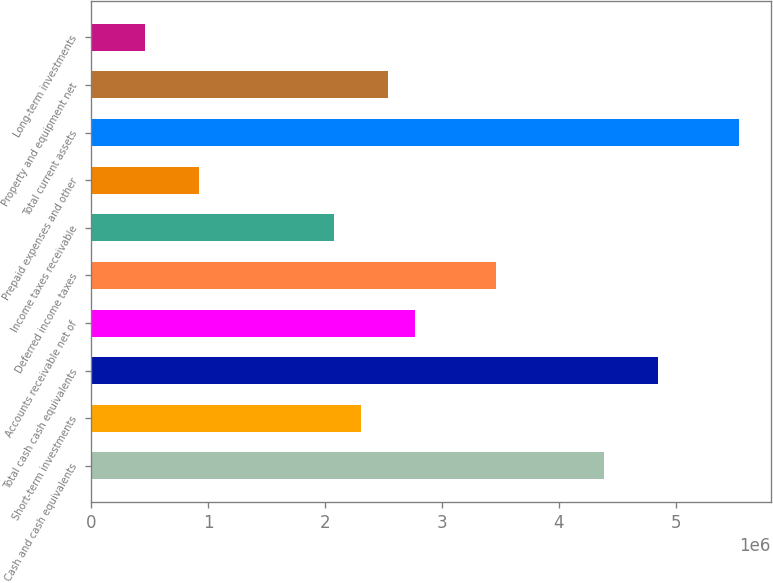<chart> <loc_0><loc_0><loc_500><loc_500><bar_chart><fcel>Cash and cash equivalents<fcel>Short-term investments<fcel>Total cash cash equivalents<fcel>Accounts receivable net of<fcel>Deferred income taxes<fcel>Income taxes receivable<fcel>Prepaid expenses and other<fcel>Total current assets<fcel>Property and equipment net<fcel>Long-term investments<nl><fcel>4.38257e+06<fcel>2.30735e+06<fcel>4.84373e+06<fcel>2.76851e+06<fcel>3.46025e+06<fcel>2.07677e+06<fcel>923877<fcel>5.53546e+06<fcel>2.53793e+06<fcel>462719<nl></chart> 